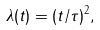<formula> <loc_0><loc_0><loc_500><loc_500>\lambda ( t ) = ( t / \tau ) ^ { 2 } ,</formula> 